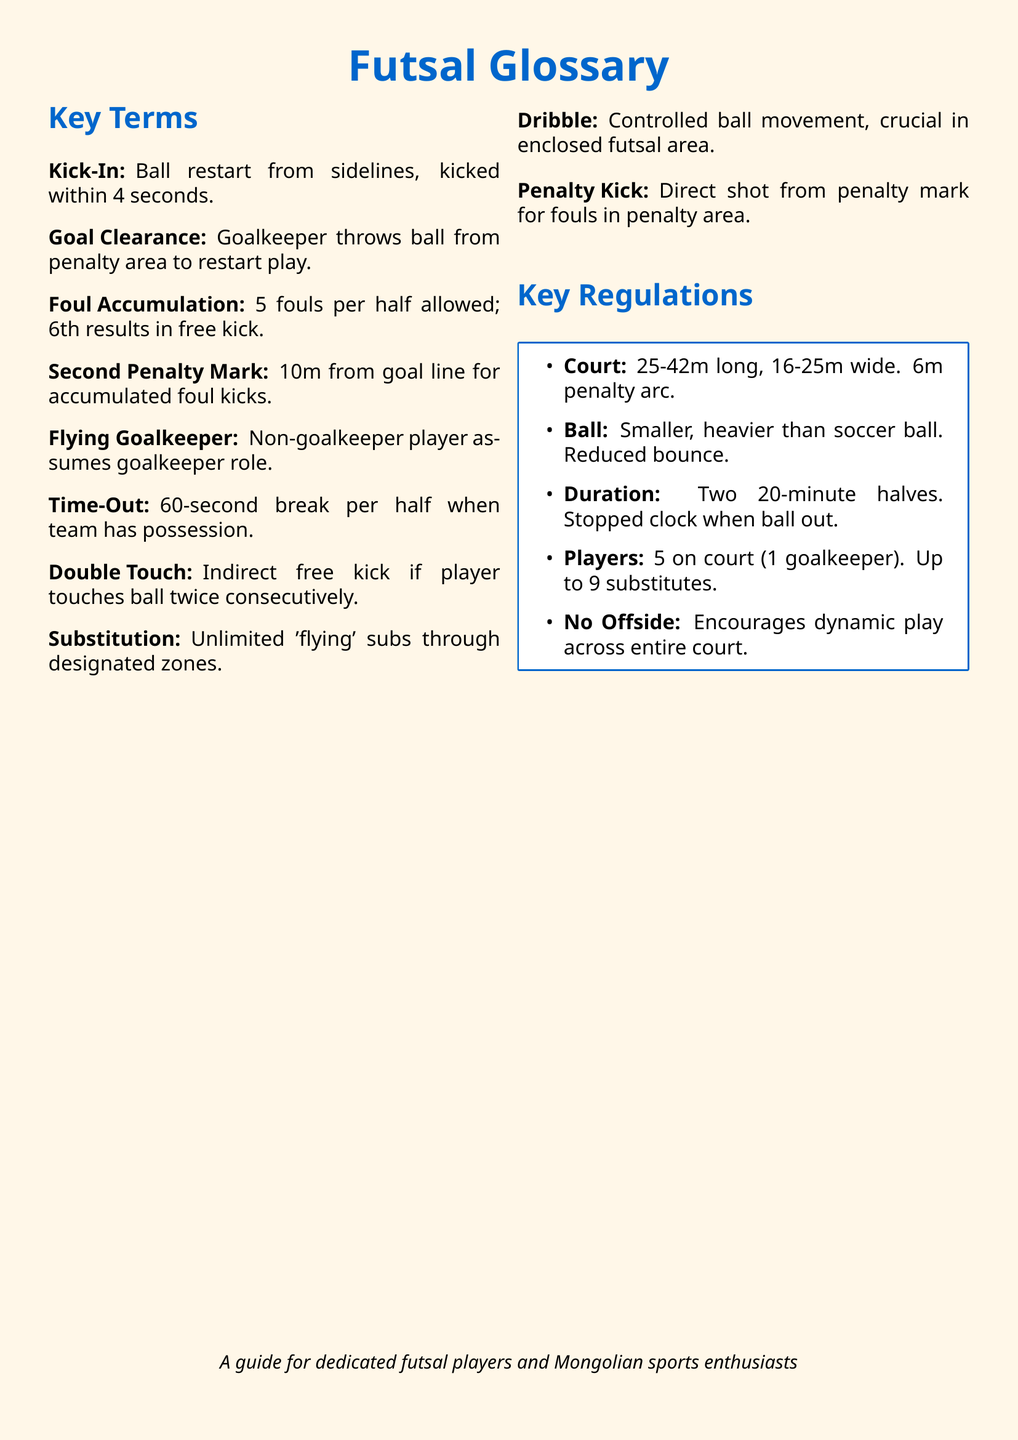What is a Kick-In? A Kick-In is a ball restart from the sidelines, which must be executed within 4 seconds.
Answer: Ball restart from sidelines, kicked within 4 seconds What is the penalty arc measurement? The penalty arc extends 6 meters from the goal line.
Answer: 6m penalty arc How many fouls are allowed per half? The document states that each team is allowed 5 fouls per half before a penalty is awarded.
Answer: 5 fouls What is the duration of a futsal match? A futsal match consists of two 20-minute halves with a stopped clock when the ball is out of play.
Answer: Two 20-minute halves Who can assume the role of the goalkeeper during a game? A non-goalkeeper player can assume the role of the goalkeeper, which is known as the flying goalkeeper.
Answer: Non-goalkeeper player What is the total number of players allowed on the court? A total of 5 players are allowed on the court, including the goalkeeper, with up to 9 substitutes available.
Answer: 5 players What is the court size range? The court length can range from 25 to 42 meters and the width from 16 to 25 meters.
Answer: 25-42m long, 16-25m wide What happens if a player touches the ball twice consecutively? If a player touches the ball twice consecutively, it results in an indirect free kick.
Answer: Indirect free kick Is there an offside rule in futsal? The document mentions that there is no offside rule in futsal, allowing for more dynamic play.
Answer: No Offside 